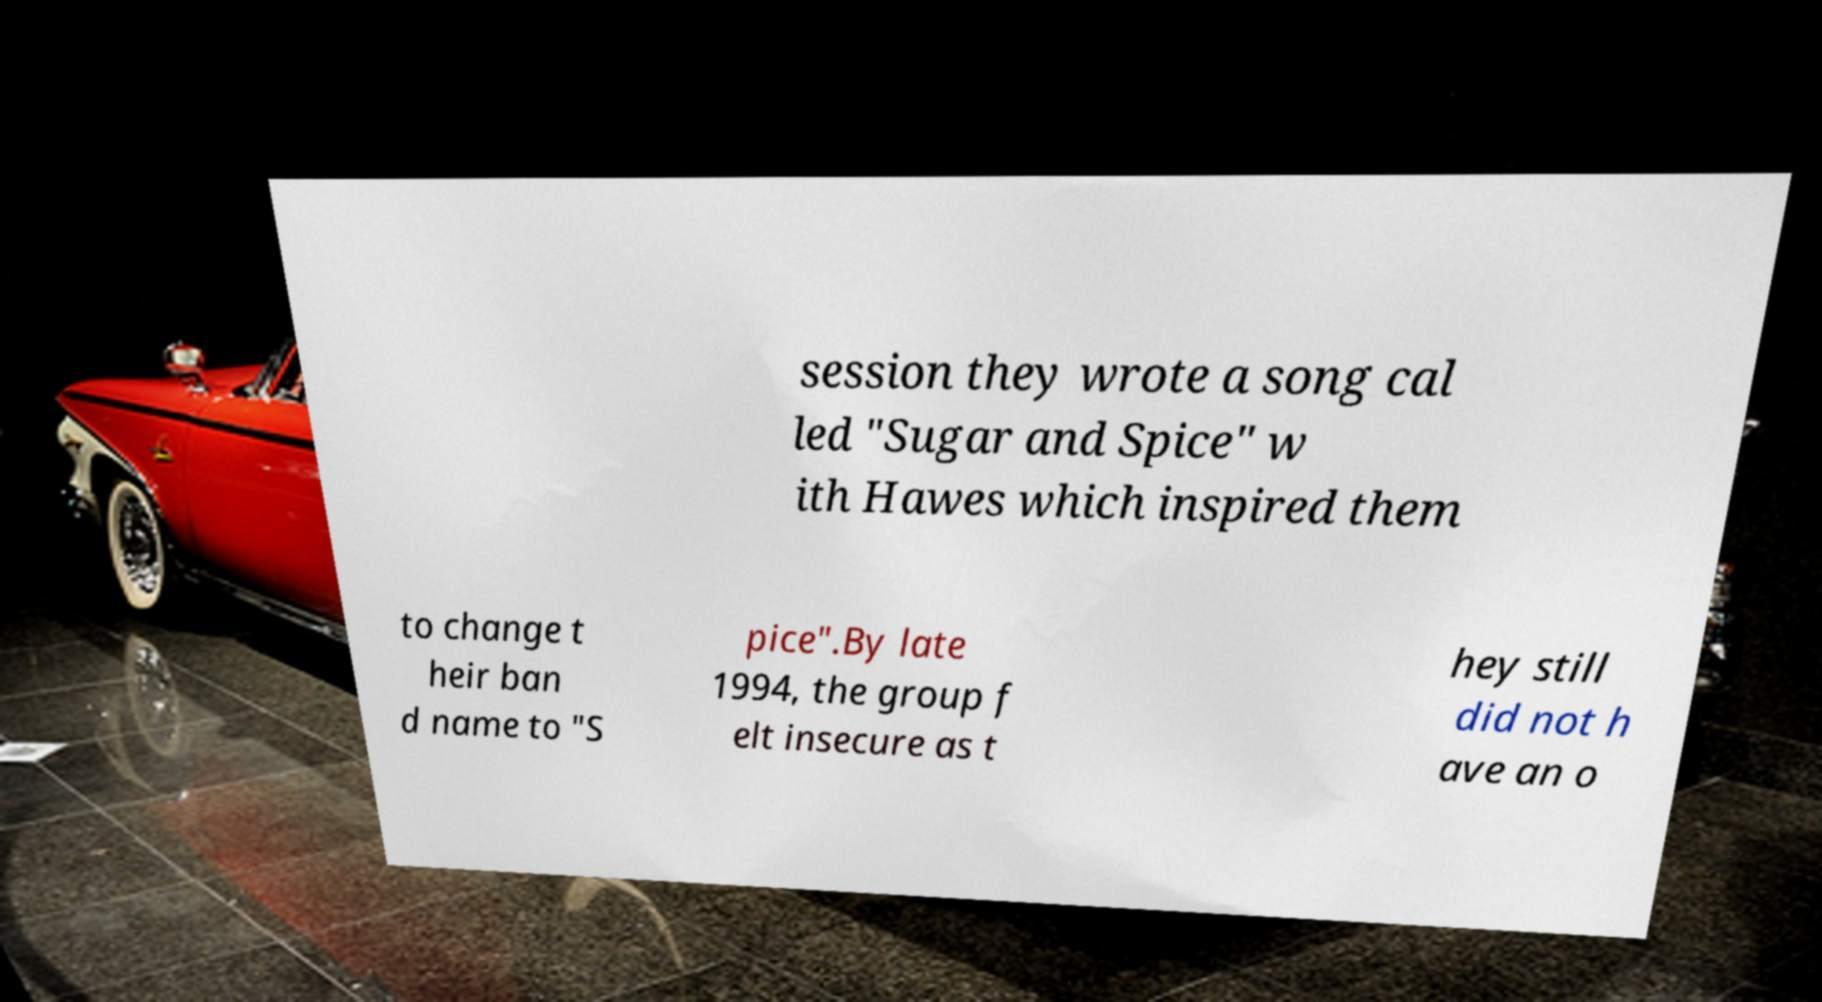Can you read and provide the text displayed in the image?This photo seems to have some interesting text. Can you extract and type it out for me? session they wrote a song cal led "Sugar and Spice" w ith Hawes which inspired them to change t heir ban d name to "S pice".By late 1994, the group f elt insecure as t hey still did not h ave an o 